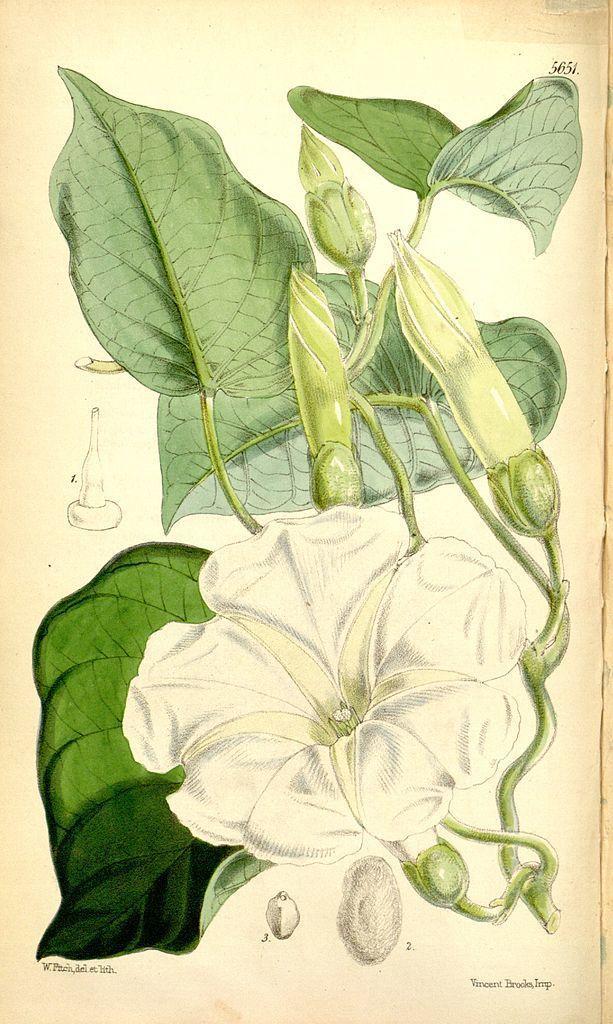Could you give a brief overview of what you see in this image? In this image we can see an art of a flower and leaves. Here we can see the watermarks. 